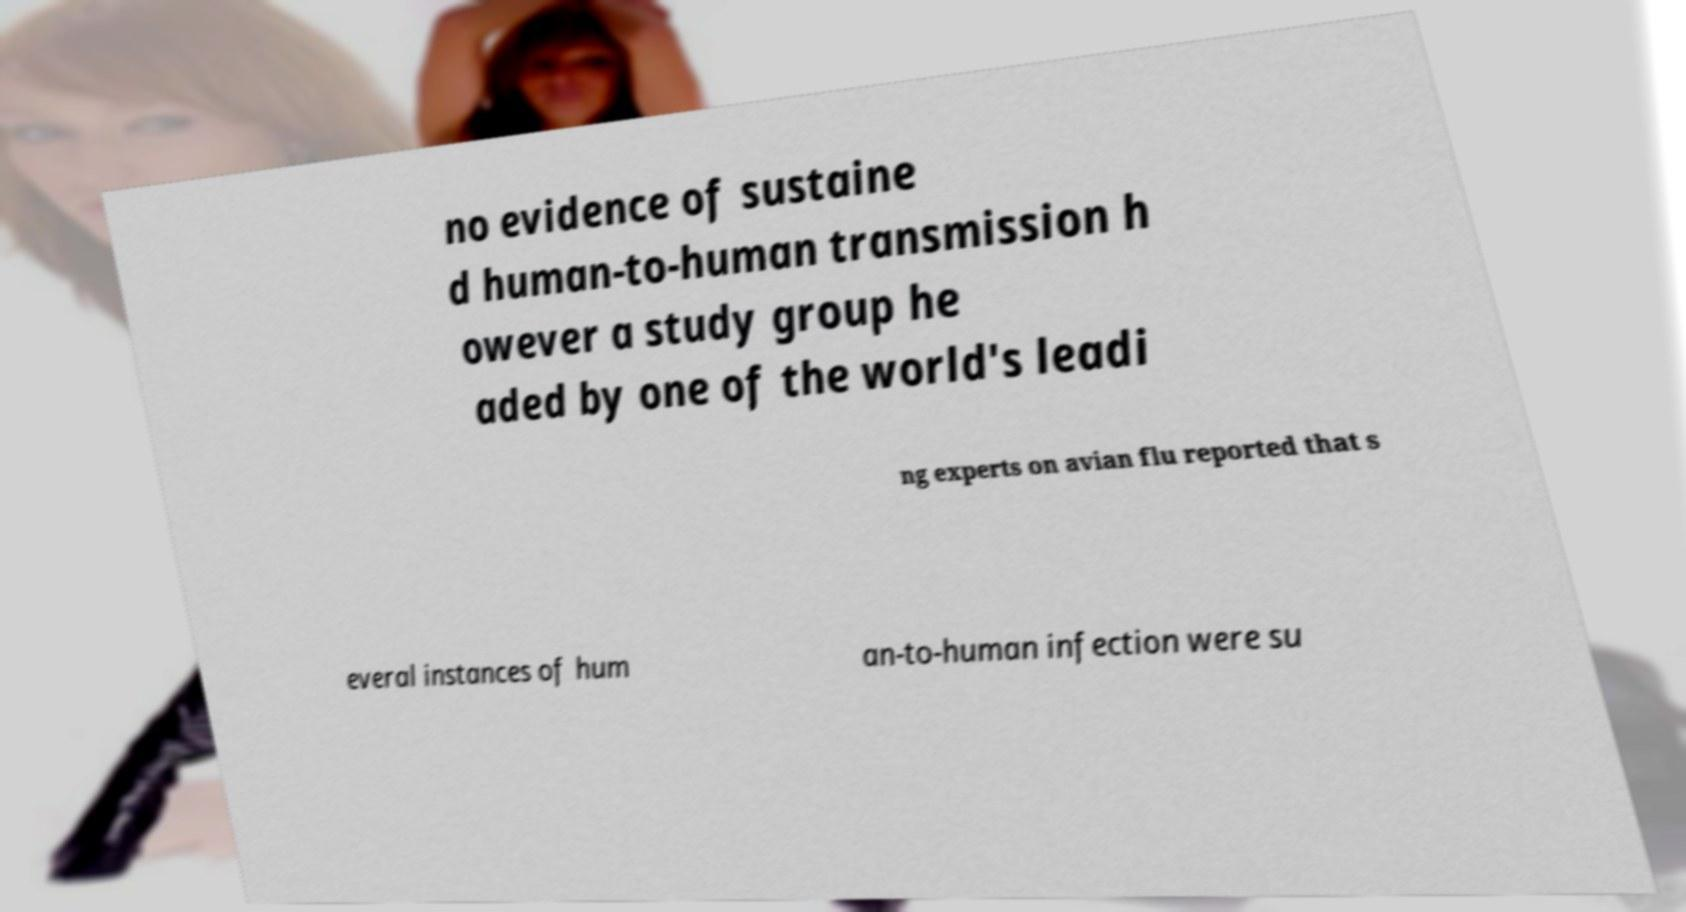Could you extract and type out the text from this image? no evidence of sustaine d human-to-human transmission h owever a study group he aded by one of the world's leadi ng experts on avian flu reported that s everal instances of hum an-to-human infection were su 